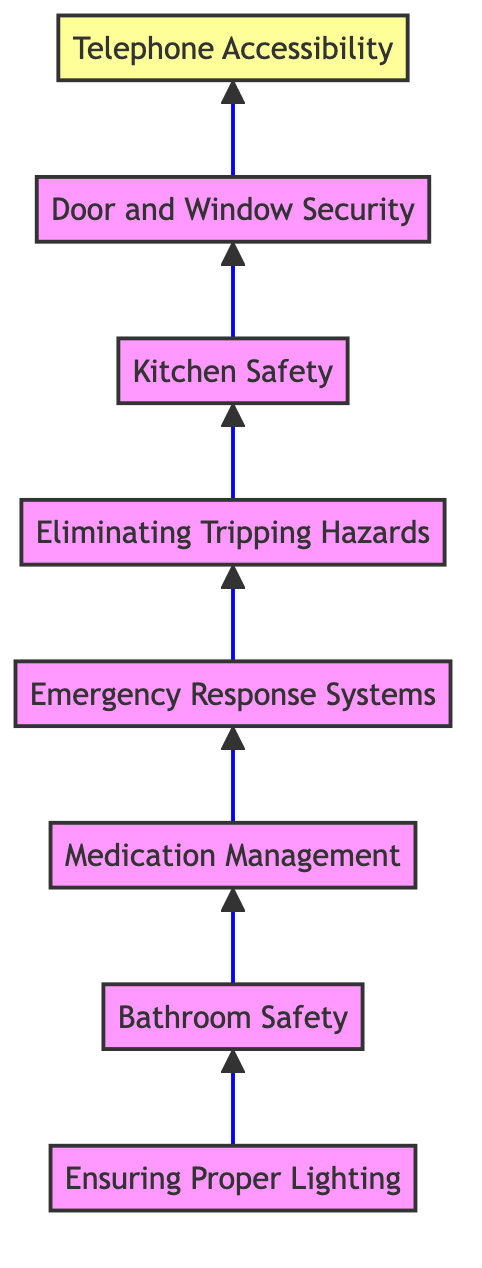What is the first safety improvement listed in the diagram? The first safety improvement listed in the diagram is "Ensuring Proper Lighting," which is the starting element at the bottom of the flow chart.
Answer: Ensuring Proper Lighting How many safety improvements are mentioned in the diagram? The diagram contains eight distinct safety improvements, as there are eight nodes in total from the bottom to the top.
Answer: Eight What is the last improvement in the flow chart? The final improvement at the top of the flow chart is "Telephone Accessibility," which is the last node in the upward flow of the chart.
Answer: Telephone Accessibility Which two improvements are directly connected? "Bathroom Safety" is directly connected to "Medication Management," indicating a sequential flow from one safety improvement to the next.
Answer: Bathroom Safety and Medication Management What improvement addresses the risk of falls? "Ensuring Proper Lighting" helps prevent falls, as it involves installing motion-sensor lights in areas where falls are more likely, such as hallways and staircases.
Answer: Ensuring Proper Lighting Which improvement requires using a device to help in the kitchen? "Kitchen Safety" mentions using automatic shut-off devices for ovens and stove tops to help prevent kitchen fires, indicating its focus on kitchen safety.
Answer: Kitchen Safety What is the improvement linked to emergency assistance? The improvement related to emergency assistance is "Emergency Response Systems," which focuses on installing systems that can call for help when needed.
Answer: Emergency Response Systems Which improvement is important for securing access points to the home? "Door and Window Security" focuses on securing locks and using a video doorbell to monitor visitors, addressing the need for safety at access points.
Answer: Door and Window Security 